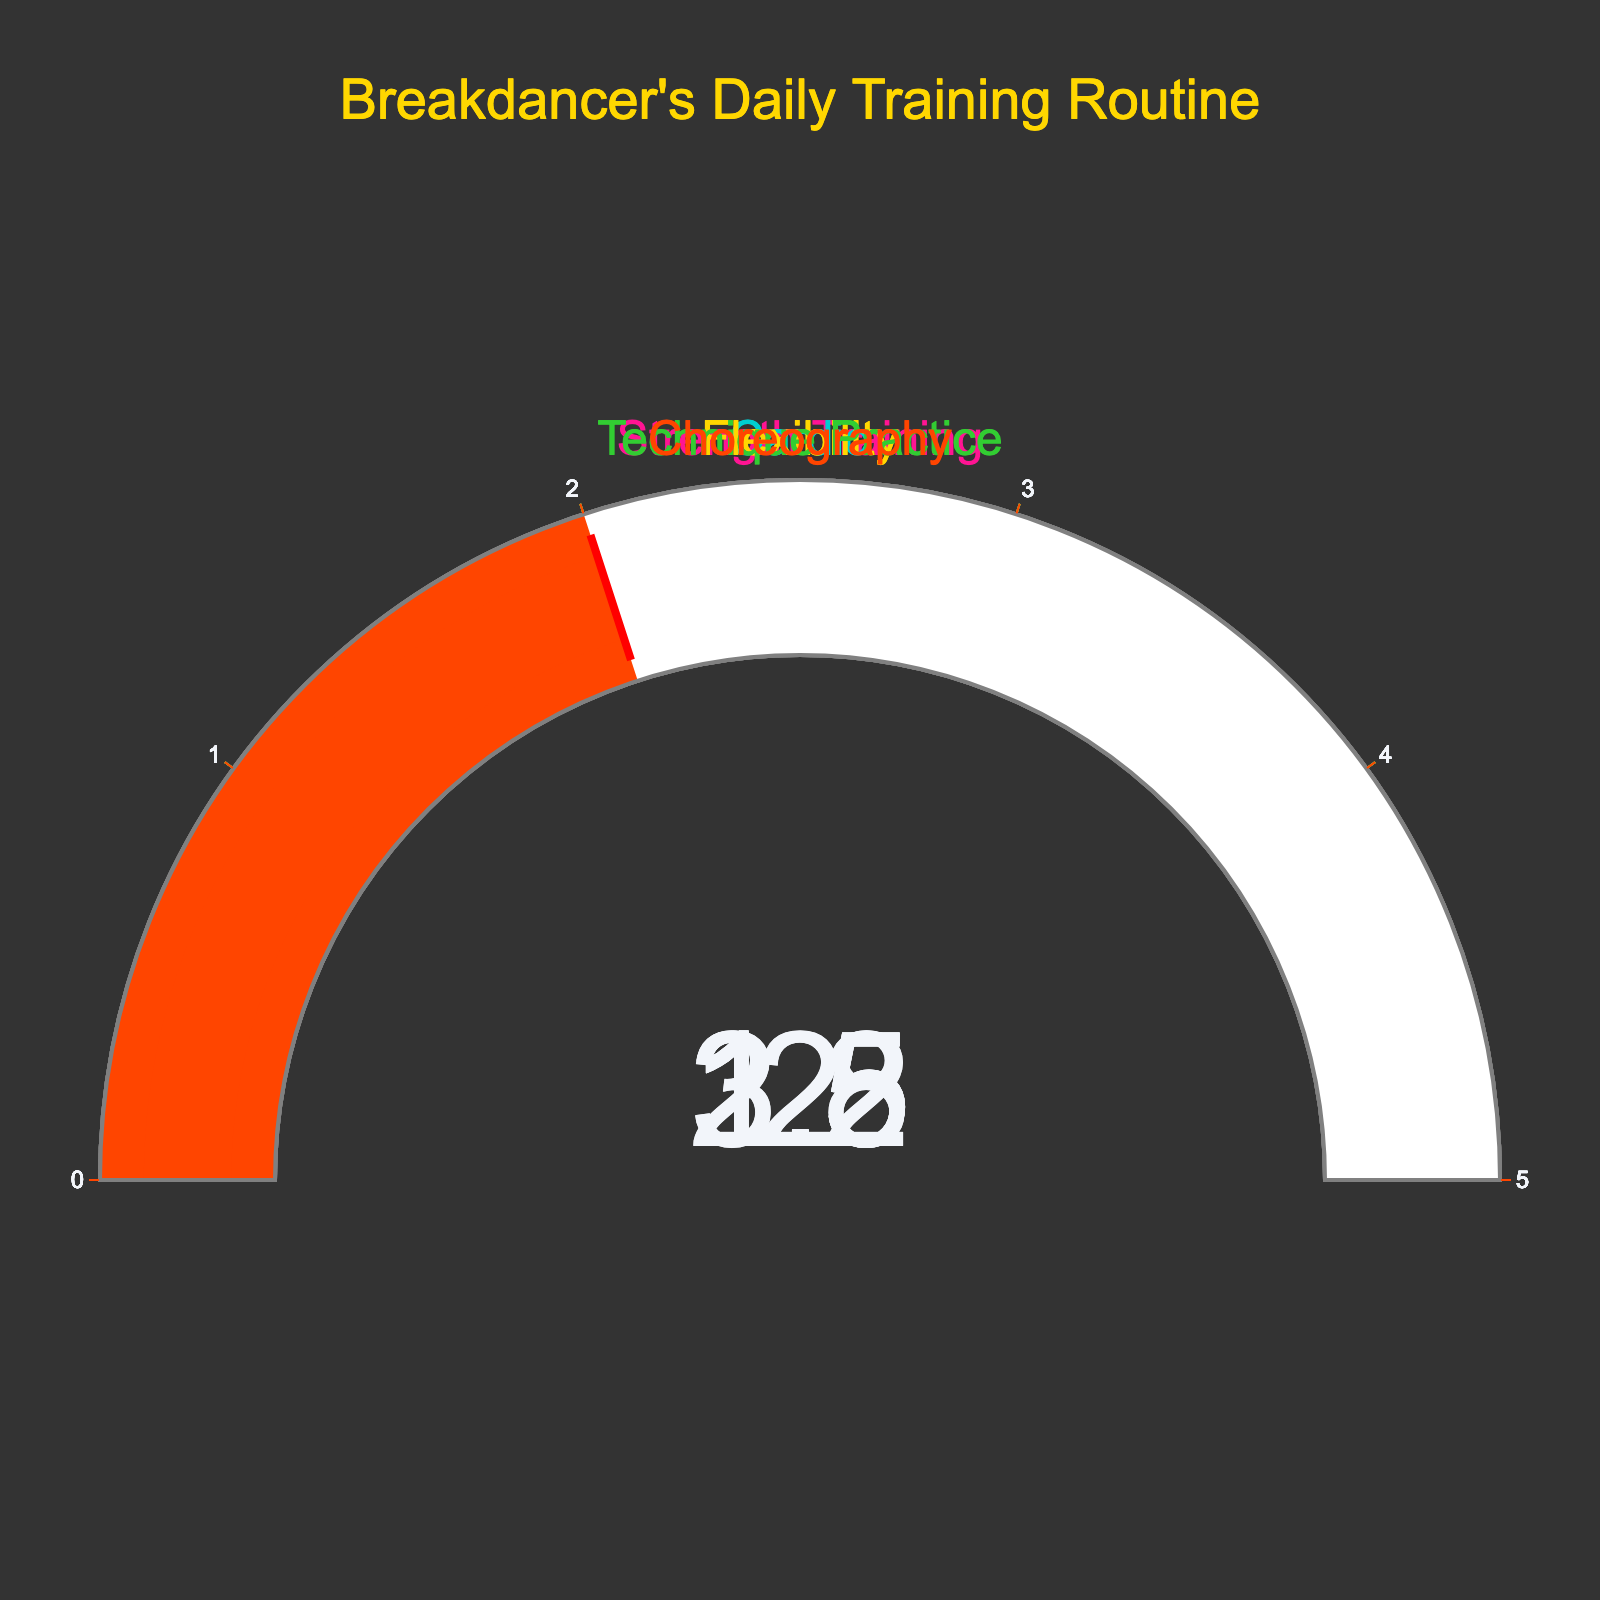What is the title of the figure? The title is written at the top of the figure in large font and gold color. It reads "Breakdancer's Daily Training Routine".
Answer: Breakdancer's Daily Training Routine What is the range of hours displayed on the gauges? Each gauge has its axis ranging from 0 to 5 hours, which is indicated on the outer ring of the gauges.
Answer: 0 to 5 hours Which training category has the highest number of average hours? The gauge with the highest average hours has the label 'Technique Practice', and its hand points to 3.2 hours.
Answer: Technique Practice How many training categories are displayed in the figure? By counting the number of separate gauges in the figure, there are five gauges, each representing a different training category.
Answer: Five What is the overall average of daily training hours across all categories? To find the overall average, sum the hours of all categories and divide by the number of categories: (2.5 + 1.5 + 1.8 + 3.2 + 2.0) / 5 = 2.2
Answer: 2.2 hours What is the difference in training hours between Strength Training and Cardio? Subtract the hours for Cardio from the hours for Strength Training: 2.5 - 1.5 = 1.0
Answer: 1.0 hour Which training category is focused on improving technique? The training category with the highest number of hours is labeled 'Technique Practice', evident from its position in the gauge chart, focusing on improving technique.
Answer: Technique Practice What is the color used for the Cardio gauge? The gauge for 'Cardio' is filled and bordered with a bright cyan color (shown in the visual representation of the gauge).
Answer: Cyan Is Flexibility training hours greater than or less than Choreography training hours? By comparing the values on the respective gauges, Flexibility has 1.8 hours and Choreography has 2.0 hours. Hence, Flexibility training hours are less than Choreography training hours.
Answer: Less What is the total number of hours spent on Strength Training and Technique Practice combined? Add the hours for Strength Training and Technique Practice: 2.5 + 3.2 = 5.7
Answer: 5.7 hours 